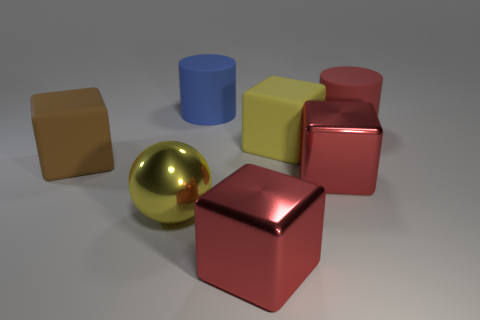Add 1 large yellow rubber objects. How many objects exist? 8 Subtract all small blue spheres. Subtract all large yellow objects. How many objects are left? 5 Add 4 big blue cylinders. How many big blue cylinders are left? 5 Add 6 big red shiny blocks. How many big red shiny blocks exist? 8 Subtract all blue cylinders. How many cylinders are left? 1 Subtract 0 gray cylinders. How many objects are left? 7 Subtract all spheres. How many objects are left? 6 Subtract 1 spheres. How many spheres are left? 0 Subtract all green cylinders. Subtract all cyan balls. How many cylinders are left? 2 Subtract all blue blocks. How many brown cylinders are left? 0 